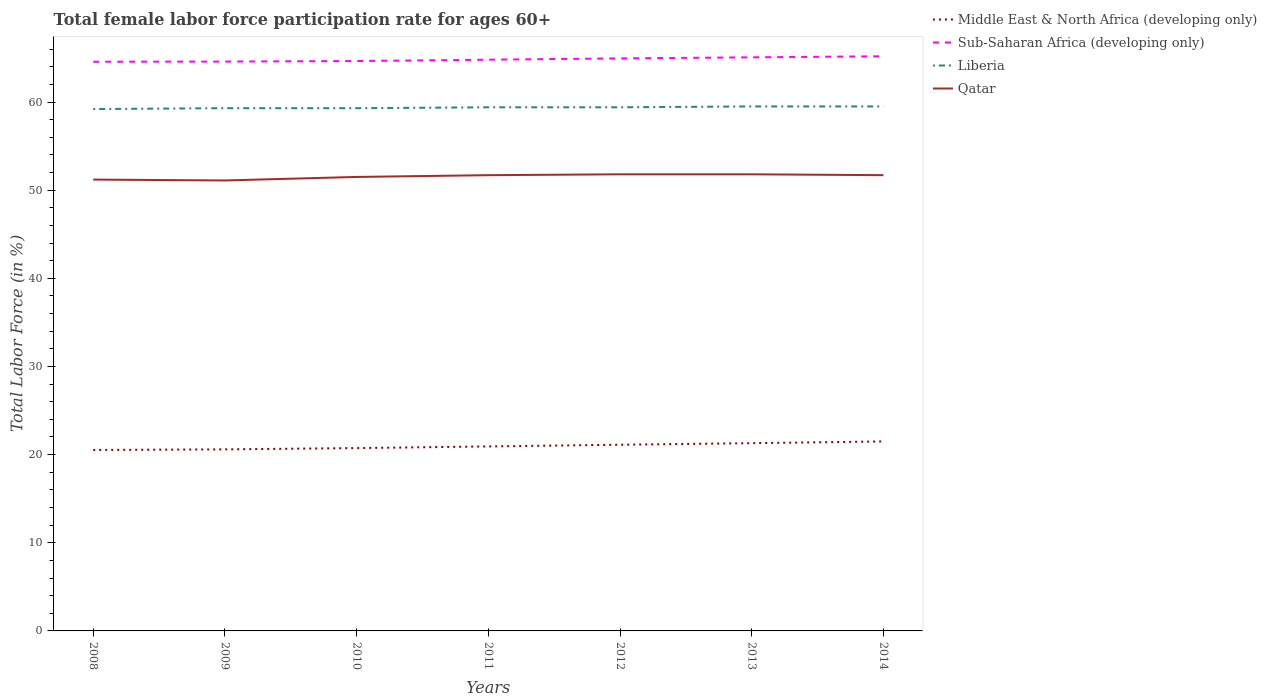Is the number of lines equal to the number of legend labels?
Offer a terse response. Yes. Across all years, what is the maximum female labor force participation rate in Liberia?
Make the answer very short. 59.2. What is the total female labor force participation rate in Middle East & North Africa (developing only) in the graph?
Your answer should be compact. -0.19. What is the difference between the highest and the second highest female labor force participation rate in Liberia?
Offer a terse response. 0.3. What is the difference between the highest and the lowest female labor force participation rate in Qatar?
Provide a succinct answer. 4. Is the female labor force participation rate in Qatar strictly greater than the female labor force participation rate in Liberia over the years?
Provide a succinct answer. Yes. How many years are there in the graph?
Provide a succinct answer. 7. What is the difference between two consecutive major ticks on the Y-axis?
Keep it short and to the point. 10. Are the values on the major ticks of Y-axis written in scientific E-notation?
Ensure brevity in your answer.  No. Where does the legend appear in the graph?
Make the answer very short. Top right. How are the legend labels stacked?
Your response must be concise. Vertical. What is the title of the graph?
Offer a very short reply. Total female labor force participation rate for ages 60+. Does "Euro area" appear as one of the legend labels in the graph?
Offer a very short reply. No. What is the Total Labor Force (in %) of Middle East & North Africa (developing only) in 2008?
Give a very brief answer. 20.53. What is the Total Labor Force (in %) in Sub-Saharan Africa (developing only) in 2008?
Make the answer very short. 64.57. What is the Total Labor Force (in %) in Liberia in 2008?
Your answer should be compact. 59.2. What is the Total Labor Force (in %) in Qatar in 2008?
Provide a succinct answer. 51.2. What is the Total Labor Force (in %) of Middle East & North Africa (developing only) in 2009?
Make the answer very short. 20.59. What is the Total Labor Force (in %) of Sub-Saharan Africa (developing only) in 2009?
Keep it short and to the point. 64.59. What is the Total Labor Force (in %) of Liberia in 2009?
Keep it short and to the point. 59.3. What is the Total Labor Force (in %) of Qatar in 2009?
Provide a short and direct response. 51.1. What is the Total Labor Force (in %) in Middle East & North Africa (developing only) in 2010?
Offer a terse response. 20.74. What is the Total Labor Force (in %) in Sub-Saharan Africa (developing only) in 2010?
Offer a very short reply. 64.65. What is the Total Labor Force (in %) in Liberia in 2010?
Your response must be concise. 59.3. What is the Total Labor Force (in %) of Qatar in 2010?
Your response must be concise. 51.5. What is the Total Labor Force (in %) in Middle East & North Africa (developing only) in 2011?
Your response must be concise. 20.93. What is the Total Labor Force (in %) of Sub-Saharan Africa (developing only) in 2011?
Provide a succinct answer. 64.8. What is the Total Labor Force (in %) in Liberia in 2011?
Offer a very short reply. 59.4. What is the Total Labor Force (in %) in Qatar in 2011?
Your response must be concise. 51.7. What is the Total Labor Force (in %) of Middle East & North Africa (developing only) in 2012?
Your answer should be very brief. 21.12. What is the Total Labor Force (in %) in Sub-Saharan Africa (developing only) in 2012?
Offer a terse response. 64.95. What is the Total Labor Force (in %) in Liberia in 2012?
Offer a terse response. 59.4. What is the Total Labor Force (in %) in Qatar in 2012?
Offer a terse response. 51.8. What is the Total Labor Force (in %) in Middle East & North Africa (developing only) in 2013?
Make the answer very short. 21.3. What is the Total Labor Force (in %) in Sub-Saharan Africa (developing only) in 2013?
Your answer should be compact. 65.07. What is the Total Labor Force (in %) in Liberia in 2013?
Your response must be concise. 59.5. What is the Total Labor Force (in %) in Qatar in 2013?
Your answer should be compact. 51.8. What is the Total Labor Force (in %) in Middle East & North Africa (developing only) in 2014?
Offer a very short reply. 21.5. What is the Total Labor Force (in %) in Sub-Saharan Africa (developing only) in 2014?
Offer a terse response. 65.19. What is the Total Labor Force (in %) in Liberia in 2014?
Give a very brief answer. 59.5. What is the Total Labor Force (in %) of Qatar in 2014?
Offer a terse response. 51.7. Across all years, what is the maximum Total Labor Force (in %) of Middle East & North Africa (developing only)?
Offer a terse response. 21.5. Across all years, what is the maximum Total Labor Force (in %) of Sub-Saharan Africa (developing only)?
Offer a very short reply. 65.19. Across all years, what is the maximum Total Labor Force (in %) of Liberia?
Provide a short and direct response. 59.5. Across all years, what is the maximum Total Labor Force (in %) in Qatar?
Provide a short and direct response. 51.8. Across all years, what is the minimum Total Labor Force (in %) of Middle East & North Africa (developing only)?
Provide a short and direct response. 20.53. Across all years, what is the minimum Total Labor Force (in %) of Sub-Saharan Africa (developing only)?
Provide a short and direct response. 64.57. Across all years, what is the minimum Total Labor Force (in %) of Liberia?
Your response must be concise. 59.2. Across all years, what is the minimum Total Labor Force (in %) in Qatar?
Your answer should be compact. 51.1. What is the total Total Labor Force (in %) in Middle East & North Africa (developing only) in the graph?
Your answer should be very brief. 146.71. What is the total Total Labor Force (in %) in Sub-Saharan Africa (developing only) in the graph?
Keep it short and to the point. 453.81. What is the total Total Labor Force (in %) in Liberia in the graph?
Your answer should be very brief. 415.6. What is the total Total Labor Force (in %) in Qatar in the graph?
Your response must be concise. 360.8. What is the difference between the Total Labor Force (in %) of Middle East & North Africa (developing only) in 2008 and that in 2009?
Your answer should be compact. -0.06. What is the difference between the Total Labor Force (in %) of Sub-Saharan Africa (developing only) in 2008 and that in 2009?
Your response must be concise. -0.02. What is the difference between the Total Labor Force (in %) of Qatar in 2008 and that in 2009?
Provide a short and direct response. 0.1. What is the difference between the Total Labor Force (in %) in Middle East & North Africa (developing only) in 2008 and that in 2010?
Give a very brief answer. -0.21. What is the difference between the Total Labor Force (in %) in Sub-Saharan Africa (developing only) in 2008 and that in 2010?
Provide a succinct answer. -0.08. What is the difference between the Total Labor Force (in %) of Qatar in 2008 and that in 2010?
Your answer should be very brief. -0.3. What is the difference between the Total Labor Force (in %) in Middle East & North Africa (developing only) in 2008 and that in 2011?
Provide a succinct answer. -0.4. What is the difference between the Total Labor Force (in %) of Sub-Saharan Africa (developing only) in 2008 and that in 2011?
Provide a short and direct response. -0.23. What is the difference between the Total Labor Force (in %) in Liberia in 2008 and that in 2011?
Ensure brevity in your answer.  -0.2. What is the difference between the Total Labor Force (in %) of Qatar in 2008 and that in 2011?
Provide a short and direct response. -0.5. What is the difference between the Total Labor Force (in %) in Middle East & North Africa (developing only) in 2008 and that in 2012?
Make the answer very short. -0.59. What is the difference between the Total Labor Force (in %) of Sub-Saharan Africa (developing only) in 2008 and that in 2012?
Your answer should be compact. -0.38. What is the difference between the Total Labor Force (in %) of Qatar in 2008 and that in 2012?
Your answer should be compact. -0.6. What is the difference between the Total Labor Force (in %) in Middle East & North Africa (developing only) in 2008 and that in 2013?
Keep it short and to the point. -0.77. What is the difference between the Total Labor Force (in %) in Sub-Saharan Africa (developing only) in 2008 and that in 2013?
Keep it short and to the point. -0.5. What is the difference between the Total Labor Force (in %) in Liberia in 2008 and that in 2013?
Offer a very short reply. -0.3. What is the difference between the Total Labor Force (in %) of Qatar in 2008 and that in 2013?
Offer a very short reply. -0.6. What is the difference between the Total Labor Force (in %) of Middle East & North Africa (developing only) in 2008 and that in 2014?
Your answer should be very brief. -0.97. What is the difference between the Total Labor Force (in %) in Sub-Saharan Africa (developing only) in 2008 and that in 2014?
Provide a short and direct response. -0.62. What is the difference between the Total Labor Force (in %) in Qatar in 2008 and that in 2014?
Offer a terse response. -0.5. What is the difference between the Total Labor Force (in %) of Middle East & North Africa (developing only) in 2009 and that in 2010?
Make the answer very short. -0.15. What is the difference between the Total Labor Force (in %) in Sub-Saharan Africa (developing only) in 2009 and that in 2010?
Provide a succinct answer. -0.06. What is the difference between the Total Labor Force (in %) of Liberia in 2009 and that in 2010?
Give a very brief answer. 0. What is the difference between the Total Labor Force (in %) of Qatar in 2009 and that in 2010?
Make the answer very short. -0.4. What is the difference between the Total Labor Force (in %) of Middle East & North Africa (developing only) in 2009 and that in 2011?
Offer a very short reply. -0.34. What is the difference between the Total Labor Force (in %) of Sub-Saharan Africa (developing only) in 2009 and that in 2011?
Ensure brevity in your answer.  -0.21. What is the difference between the Total Labor Force (in %) in Liberia in 2009 and that in 2011?
Provide a short and direct response. -0.1. What is the difference between the Total Labor Force (in %) in Qatar in 2009 and that in 2011?
Provide a succinct answer. -0.6. What is the difference between the Total Labor Force (in %) in Middle East & North Africa (developing only) in 2009 and that in 2012?
Provide a succinct answer. -0.53. What is the difference between the Total Labor Force (in %) of Sub-Saharan Africa (developing only) in 2009 and that in 2012?
Your response must be concise. -0.36. What is the difference between the Total Labor Force (in %) of Liberia in 2009 and that in 2012?
Give a very brief answer. -0.1. What is the difference between the Total Labor Force (in %) in Qatar in 2009 and that in 2012?
Offer a very short reply. -0.7. What is the difference between the Total Labor Force (in %) in Middle East & North Africa (developing only) in 2009 and that in 2013?
Offer a very short reply. -0.7. What is the difference between the Total Labor Force (in %) in Sub-Saharan Africa (developing only) in 2009 and that in 2013?
Make the answer very short. -0.48. What is the difference between the Total Labor Force (in %) in Liberia in 2009 and that in 2013?
Make the answer very short. -0.2. What is the difference between the Total Labor Force (in %) of Middle East & North Africa (developing only) in 2009 and that in 2014?
Make the answer very short. -0.9. What is the difference between the Total Labor Force (in %) in Sub-Saharan Africa (developing only) in 2009 and that in 2014?
Your answer should be very brief. -0.6. What is the difference between the Total Labor Force (in %) in Liberia in 2009 and that in 2014?
Ensure brevity in your answer.  -0.2. What is the difference between the Total Labor Force (in %) of Qatar in 2009 and that in 2014?
Your response must be concise. -0.6. What is the difference between the Total Labor Force (in %) of Middle East & North Africa (developing only) in 2010 and that in 2011?
Provide a succinct answer. -0.19. What is the difference between the Total Labor Force (in %) in Sub-Saharan Africa (developing only) in 2010 and that in 2011?
Ensure brevity in your answer.  -0.15. What is the difference between the Total Labor Force (in %) of Liberia in 2010 and that in 2011?
Your answer should be very brief. -0.1. What is the difference between the Total Labor Force (in %) in Qatar in 2010 and that in 2011?
Give a very brief answer. -0.2. What is the difference between the Total Labor Force (in %) in Middle East & North Africa (developing only) in 2010 and that in 2012?
Your answer should be compact. -0.38. What is the difference between the Total Labor Force (in %) of Sub-Saharan Africa (developing only) in 2010 and that in 2012?
Keep it short and to the point. -0.3. What is the difference between the Total Labor Force (in %) in Qatar in 2010 and that in 2012?
Make the answer very short. -0.3. What is the difference between the Total Labor Force (in %) of Middle East & North Africa (developing only) in 2010 and that in 2013?
Your answer should be very brief. -0.56. What is the difference between the Total Labor Force (in %) of Sub-Saharan Africa (developing only) in 2010 and that in 2013?
Provide a succinct answer. -0.42. What is the difference between the Total Labor Force (in %) of Liberia in 2010 and that in 2013?
Your answer should be compact. -0.2. What is the difference between the Total Labor Force (in %) of Qatar in 2010 and that in 2013?
Your response must be concise. -0.3. What is the difference between the Total Labor Force (in %) of Middle East & North Africa (developing only) in 2010 and that in 2014?
Provide a succinct answer. -0.75. What is the difference between the Total Labor Force (in %) of Sub-Saharan Africa (developing only) in 2010 and that in 2014?
Your answer should be very brief. -0.54. What is the difference between the Total Labor Force (in %) of Liberia in 2010 and that in 2014?
Offer a terse response. -0.2. What is the difference between the Total Labor Force (in %) in Middle East & North Africa (developing only) in 2011 and that in 2012?
Keep it short and to the point. -0.19. What is the difference between the Total Labor Force (in %) of Sub-Saharan Africa (developing only) in 2011 and that in 2012?
Your answer should be compact. -0.15. What is the difference between the Total Labor Force (in %) of Liberia in 2011 and that in 2012?
Ensure brevity in your answer.  0. What is the difference between the Total Labor Force (in %) of Qatar in 2011 and that in 2012?
Offer a terse response. -0.1. What is the difference between the Total Labor Force (in %) in Middle East & North Africa (developing only) in 2011 and that in 2013?
Offer a very short reply. -0.37. What is the difference between the Total Labor Force (in %) of Sub-Saharan Africa (developing only) in 2011 and that in 2013?
Keep it short and to the point. -0.27. What is the difference between the Total Labor Force (in %) of Liberia in 2011 and that in 2013?
Your response must be concise. -0.1. What is the difference between the Total Labor Force (in %) of Qatar in 2011 and that in 2013?
Give a very brief answer. -0.1. What is the difference between the Total Labor Force (in %) in Middle East & North Africa (developing only) in 2011 and that in 2014?
Provide a short and direct response. -0.57. What is the difference between the Total Labor Force (in %) in Sub-Saharan Africa (developing only) in 2011 and that in 2014?
Your answer should be compact. -0.39. What is the difference between the Total Labor Force (in %) of Qatar in 2011 and that in 2014?
Your answer should be very brief. 0. What is the difference between the Total Labor Force (in %) in Middle East & North Africa (developing only) in 2012 and that in 2013?
Give a very brief answer. -0.18. What is the difference between the Total Labor Force (in %) in Sub-Saharan Africa (developing only) in 2012 and that in 2013?
Provide a succinct answer. -0.12. What is the difference between the Total Labor Force (in %) in Liberia in 2012 and that in 2013?
Give a very brief answer. -0.1. What is the difference between the Total Labor Force (in %) in Middle East & North Africa (developing only) in 2012 and that in 2014?
Your answer should be compact. -0.38. What is the difference between the Total Labor Force (in %) of Sub-Saharan Africa (developing only) in 2012 and that in 2014?
Your answer should be very brief. -0.24. What is the difference between the Total Labor Force (in %) of Liberia in 2012 and that in 2014?
Offer a terse response. -0.1. What is the difference between the Total Labor Force (in %) in Middle East & North Africa (developing only) in 2013 and that in 2014?
Make the answer very short. -0.2. What is the difference between the Total Labor Force (in %) of Sub-Saharan Africa (developing only) in 2013 and that in 2014?
Your answer should be compact. -0.12. What is the difference between the Total Labor Force (in %) of Qatar in 2013 and that in 2014?
Ensure brevity in your answer.  0.1. What is the difference between the Total Labor Force (in %) in Middle East & North Africa (developing only) in 2008 and the Total Labor Force (in %) in Sub-Saharan Africa (developing only) in 2009?
Your response must be concise. -44.06. What is the difference between the Total Labor Force (in %) of Middle East & North Africa (developing only) in 2008 and the Total Labor Force (in %) of Liberia in 2009?
Give a very brief answer. -38.77. What is the difference between the Total Labor Force (in %) in Middle East & North Africa (developing only) in 2008 and the Total Labor Force (in %) in Qatar in 2009?
Make the answer very short. -30.57. What is the difference between the Total Labor Force (in %) in Sub-Saharan Africa (developing only) in 2008 and the Total Labor Force (in %) in Liberia in 2009?
Your response must be concise. 5.27. What is the difference between the Total Labor Force (in %) in Sub-Saharan Africa (developing only) in 2008 and the Total Labor Force (in %) in Qatar in 2009?
Ensure brevity in your answer.  13.47. What is the difference between the Total Labor Force (in %) in Middle East & North Africa (developing only) in 2008 and the Total Labor Force (in %) in Sub-Saharan Africa (developing only) in 2010?
Provide a succinct answer. -44.12. What is the difference between the Total Labor Force (in %) of Middle East & North Africa (developing only) in 2008 and the Total Labor Force (in %) of Liberia in 2010?
Your response must be concise. -38.77. What is the difference between the Total Labor Force (in %) of Middle East & North Africa (developing only) in 2008 and the Total Labor Force (in %) of Qatar in 2010?
Your answer should be very brief. -30.97. What is the difference between the Total Labor Force (in %) in Sub-Saharan Africa (developing only) in 2008 and the Total Labor Force (in %) in Liberia in 2010?
Your answer should be compact. 5.27. What is the difference between the Total Labor Force (in %) in Sub-Saharan Africa (developing only) in 2008 and the Total Labor Force (in %) in Qatar in 2010?
Ensure brevity in your answer.  13.07. What is the difference between the Total Labor Force (in %) in Middle East & North Africa (developing only) in 2008 and the Total Labor Force (in %) in Sub-Saharan Africa (developing only) in 2011?
Provide a succinct answer. -44.27. What is the difference between the Total Labor Force (in %) of Middle East & North Africa (developing only) in 2008 and the Total Labor Force (in %) of Liberia in 2011?
Offer a very short reply. -38.87. What is the difference between the Total Labor Force (in %) of Middle East & North Africa (developing only) in 2008 and the Total Labor Force (in %) of Qatar in 2011?
Offer a terse response. -31.17. What is the difference between the Total Labor Force (in %) of Sub-Saharan Africa (developing only) in 2008 and the Total Labor Force (in %) of Liberia in 2011?
Ensure brevity in your answer.  5.17. What is the difference between the Total Labor Force (in %) in Sub-Saharan Africa (developing only) in 2008 and the Total Labor Force (in %) in Qatar in 2011?
Your response must be concise. 12.87. What is the difference between the Total Labor Force (in %) in Liberia in 2008 and the Total Labor Force (in %) in Qatar in 2011?
Your answer should be very brief. 7.5. What is the difference between the Total Labor Force (in %) in Middle East & North Africa (developing only) in 2008 and the Total Labor Force (in %) in Sub-Saharan Africa (developing only) in 2012?
Ensure brevity in your answer.  -44.42. What is the difference between the Total Labor Force (in %) of Middle East & North Africa (developing only) in 2008 and the Total Labor Force (in %) of Liberia in 2012?
Offer a terse response. -38.87. What is the difference between the Total Labor Force (in %) in Middle East & North Africa (developing only) in 2008 and the Total Labor Force (in %) in Qatar in 2012?
Keep it short and to the point. -31.27. What is the difference between the Total Labor Force (in %) of Sub-Saharan Africa (developing only) in 2008 and the Total Labor Force (in %) of Liberia in 2012?
Provide a succinct answer. 5.17. What is the difference between the Total Labor Force (in %) of Sub-Saharan Africa (developing only) in 2008 and the Total Labor Force (in %) of Qatar in 2012?
Ensure brevity in your answer.  12.77. What is the difference between the Total Labor Force (in %) in Liberia in 2008 and the Total Labor Force (in %) in Qatar in 2012?
Your response must be concise. 7.4. What is the difference between the Total Labor Force (in %) in Middle East & North Africa (developing only) in 2008 and the Total Labor Force (in %) in Sub-Saharan Africa (developing only) in 2013?
Offer a terse response. -44.54. What is the difference between the Total Labor Force (in %) in Middle East & North Africa (developing only) in 2008 and the Total Labor Force (in %) in Liberia in 2013?
Keep it short and to the point. -38.97. What is the difference between the Total Labor Force (in %) in Middle East & North Africa (developing only) in 2008 and the Total Labor Force (in %) in Qatar in 2013?
Provide a short and direct response. -31.27. What is the difference between the Total Labor Force (in %) of Sub-Saharan Africa (developing only) in 2008 and the Total Labor Force (in %) of Liberia in 2013?
Your response must be concise. 5.07. What is the difference between the Total Labor Force (in %) in Sub-Saharan Africa (developing only) in 2008 and the Total Labor Force (in %) in Qatar in 2013?
Your answer should be very brief. 12.77. What is the difference between the Total Labor Force (in %) in Middle East & North Africa (developing only) in 2008 and the Total Labor Force (in %) in Sub-Saharan Africa (developing only) in 2014?
Make the answer very short. -44.66. What is the difference between the Total Labor Force (in %) in Middle East & North Africa (developing only) in 2008 and the Total Labor Force (in %) in Liberia in 2014?
Provide a succinct answer. -38.97. What is the difference between the Total Labor Force (in %) of Middle East & North Africa (developing only) in 2008 and the Total Labor Force (in %) of Qatar in 2014?
Offer a very short reply. -31.17. What is the difference between the Total Labor Force (in %) of Sub-Saharan Africa (developing only) in 2008 and the Total Labor Force (in %) of Liberia in 2014?
Make the answer very short. 5.07. What is the difference between the Total Labor Force (in %) of Sub-Saharan Africa (developing only) in 2008 and the Total Labor Force (in %) of Qatar in 2014?
Keep it short and to the point. 12.87. What is the difference between the Total Labor Force (in %) of Middle East & North Africa (developing only) in 2009 and the Total Labor Force (in %) of Sub-Saharan Africa (developing only) in 2010?
Offer a terse response. -44.05. What is the difference between the Total Labor Force (in %) in Middle East & North Africa (developing only) in 2009 and the Total Labor Force (in %) in Liberia in 2010?
Give a very brief answer. -38.71. What is the difference between the Total Labor Force (in %) in Middle East & North Africa (developing only) in 2009 and the Total Labor Force (in %) in Qatar in 2010?
Keep it short and to the point. -30.91. What is the difference between the Total Labor Force (in %) of Sub-Saharan Africa (developing only) in 2009 and the Total Labor Force (in %) of Liberia in 2010?
Ensure brevity in your answer.  5.29. What is the difference between the Total Labor Force (in %) of Sub-Saharan Africa (developing only) in 2009 and the Total Labor Force (in %) of Qatar in 2010?
Offer a very short reply. 13.09. What is the difference between the Total Labor Force (in %) in Middle East & North Africa (developing only) in 2009 and the Total Labor Force (in %) in Sub-Saharan Africa (developing only) in 2011?
Offer a very short reply. -44.21. What is the difference between the Total Labor Force (in %) in Middle East & North Africa (developing only) in 2009 and the Total Labor Force (in %) in Liberia in 2011?
Make the answer very short. -38.81. What is the difference between the Total Labor Force (in %) of Middle East & North Africa (developing only) in 2009 and the Total Labor Force (in %) of Qatar in 2011?
Offer a terse response. -31.11. What is the difference between the Total Labor Force (in %) of Sub-Saharan Africa (developing only) in 2009 and the Total Labor Force (in %) of Liberia in 2011?
Ensure brevity in your answer.  5.19. What is the difference between the Total Labor Force (in %) in Sub-Saharan Africa (developing only) in 2009 and the Total Labor Force (in %) in Qatar in 2011?
Provide a short and direct response. 12.89. What is the difference between the Total Labor Force (in %) in Middle East & North Africa (developing only) in 2009 and the Total Labor Force (in %) in Sub-Saharan Africa (developing only) in 2012?
Provide a succinct answer. -44.35. What is the difference between the Total Labor Force (in %) of Middle East & North Africa (developing only) in 2009 and the Total Labor Force (in %) of Liberia in 2012?
Offer a very short reply. -38.81. What is the difference between the Total Labor Force (in %) in Middle East & North Africa (developing only) in 2009 and the Total Labor Force (in %) in Qatar in 2012?
Your response must be concise. -31.21. What is the difference between the Total Labor Force (in %) in Sub-Saharan Africa (developing only) in 2009 and the Total Labor Force (in %) in Liberia in 2012?
Keep it short and to the point. 5.19. What is the difference between the Total Labor Force (in %) in Sub-Saharan Africa (developing only) in 2009 and the Total Labor Force (in %) in Qatar in 2012?
Your response must be concise. 12.79. What is the difference between the Total Labor Force (in %) in Liberia in 2009 and the Total Labor Force (in %) in Qatar in 2012?
Your answer should be very brief. 7.5. What is the difference between the Total Labor Force (in %) in Middle East & North Africa (developing only) in 2009 and the Total Labor Force (in %) in Sub-Saharan Africa (developing only) in 2013?
Your answer should be compact. -44.47. What is the difference between the Total Labor Force (in %) of Middle East & North Africa (developing only) in 2009 and the Total Labor Force (in %) of Liberia in 2013?
Your response must be concise. -38.91. What is the difference between the Total Labor Force (in %) of Middle East & North Africa (developing only) in 2009 and the Total Labor Force (in %) of Qatar in 2013?
Your answer should be compact. -31.21. What is the difference between the Total Labor Force (in %) of Sub-Saharan Africa (developing only) in 2009 and the Total Labor Force (in %) of Liberia in 2013?
Ensure brevity in your answer.  5.09. What is the difference between the Total Labor Force (in %) of Sub-Saharan Africa (developing only) in 2009 and the Total Labor Force (in %) of Qatar in 2013?
Make the answer very short. 12.79. What is the difference between the Total Labor Force (in %) of Liberia in 2009 and the Total Labor Force (in %) of Qatar in 2013?
Your response must be concise. 7.5. What is the difference between the Total Labor Force (in %) in Middle East & North Africa (developing only) in 2009 and the Total Labor Force (in %) in Sub-Saharan Africa (developing only) in 2014?
Give a very brief answer. -44.6. What is the difference between the Total Labor Force (in %) of Middle East & North Africa (developing only) in 2009 and the Total Labor Force (in %) of Liberia in 2014?
Make the answer very short. -38.91. What is the difference between the Total Labor Force (in %) of Middle East & North Africa (developing only) in 2009 and the Total Labor Force (in %) of Qatar in 2014?
Make the answer very short. -31.11. What is the difference between the Total Labor Force (in %) of Sub-Saharan Africa (developing only) in 2009 and the Total Labor Force (in %) of Liberia in 2014?
Provide a succinct answer. 5.09. What is the difference between the Total Labor Force (in %) in Sub-Saharan Africa (developing only) in 2009 and the Total Labor Force (in %) in Qatar in 2014?
Keep it short and to the point. 12.89. What is the difference between the Total Labor Force (in %) in Middle East & North Africa (developing only) in 2010 and the Total Labor Force (in %) in Sub-Saharan Africa (developing only) in 2011?
Provide a succinct answer. -44.06. What is the difference between the Total Labor Force (in %) of Middle East & North Africa (developing only) in 2010 and the Total Labor Force (in %) of Liberia in 2011?
Give a very brief answer. -38.66. What is the difference between the Total Labor Force (in %) of Middle East & North Africa (developing only) in 2010 and the Total Labor Force (in %) of Qatar in 2011?
Provide a succinct answer. -30.96. What is the difference between the Total Labor Force (in %) in Sub-Saharan Africa (developing only) in 2010 and the Total Labor Force (in %) in Liberia in 2011?
Keep it short and to the point. 5.25. What is the difference between the Total Labor Force (in %) of Sub-Saharan Africa (developing only) in 2010 and the Total Labor Force (in %) of Qatar in 2011?
Keep it short and to the point. 12.95. What is the difference between the Total Labor Force (in %) of Liberia in 2010 and the Total Labor Force (in %) of Qatar in 2011?
Make the answer very short. 7.6. What is the difference between the Total Labor Force (in %) in Middle East & North Africa (developing only) in 2010 and the Total Labor Force (in %) in Sub-Saharan Africa (developing only) in 2012?
Ensure brevity in your answer.  -44.21. What is the difference between the Total Labor Force (in %) in Middle East & North Africa (developing only) in 2010 and the Total Labor Force (in %) in Liberia in 2012?
Your answer should be compact. -38.66. What is the difference between the Total Labor Force (in %) in Middle East & North Africa (developing only) in 2010 and the Total Labor Force (in %) in Qatar in 2012?
Give a very brief answer. -31.06. What is the difference between the Total Labor Force (in %) in Sub-Saharan Africa (developing only) in 2010 and the Total Labor Force (in %) in Liberia in 2012?
Your answer should be very brief. 5.25. What is the difference between the Total Labor Force (in %) of Sub-Saharan Africa (developing only) in 2010 and the Total Labor Force (in %) of Qatar in 2012?
Your response must be concise. 12.85. What is the difference between the Total Labor Force (in %) of Middle East & North Africa (developing only) in 2010 and the Total Labor Force (in %) of Sub-Saharan Africa (developing only) in 2013?
Your answer should be very brief. -44.33. What is the difference between the Total Labor Force (in %) of Middle East & North Africa (developing only) in 2010 and the Total Labor Force (in %) of Liberia in 2013?
Provide a succinct answer. -38.76. What is the difference between the Total Labor Force (in %) of Middle East & North Africa (developing only) in 2010 and the Total Labor Force (in %) of Qatar in 2013?
Your response must be concise. -31.06. What is the difference between the Total Labor Force (in %) in Sub-Saharan Africa (developing only) in 2010 and the Total Labor Force (in %) in Liberia in 2013?
Give a very brief answer. 5.15. What is the difference between the Total Labor Force (in %) of Sub-Saharan Africa (developing only) in 2010 and the Total Labor Force (in %) of Qatar in 2013?
Your answer should be very brief. 12.85. What is the difference between the Total Labor Force (in %) in Middle East & North Africa (developing only) in 2010 and the Total Labor Force (in %) in Sub-Saharan Africa (developing only) in 2014?
Your answer should be compact. -44.45. What is the difference between the Total Labor Force (in %) of Middle East & North Africa (developing only) in 2010 and the Total Labor Force (in %) of Liberia in 2014?
Offer a very short reply. -38.76. What is the difference between the Total Labor Force (in %) of Middle East & North Africa (developing only) in 2010 and the Total Labor Force (in %) of Qatar in 2014?
Your answer should be compact. -30.96. What is the difference between the Total Labor Force (in %) of Sub-Saharan Africa (developing only) in 2010 and the Total Labor Force (in %) of Liberia in 2014?
Offer a very short reply. 5.15. What is the difference between the Total Labor Force (in %) in Sub-Saharan Africa (developing only) in 2010 and the Total Labor Force (in %) in Qatar in 2014?
Offer a terse response. 12.95. What is the difference between the Total Labor Force (in %) in Middle East & North Africa (developing only) in 2011 and the Total Labor Force (in %) in Sub-Saharan Africa (developing only) in 2012?
Provide a succinct answer. -44.02. What is the difference between the Total Labor Force (in %) in Middle East & North Africa (developing only) in 2011 and the Total Labor Force (in %) in Liberia in 2012?
Offer a very short reply. -38.47. What is the difference between the Total Labor Force (in %) in Middle East & North Africa (developing only) in 2011 and the Total Labor Force (in %) in Qatar in 2012?
Your answer should be very brief. -30.87. What is the difference between the Total Labor Force (in %) in Sub-Saharan Africa (developing only) in 2011 and the Total Labor Force (in %) in Liberia in 2012?
Your answer should be very brief. 5.4. What is the difference between the Total Labor Force (in %) in Sub-Saharan Africa (developing only) in 2011 and the Total Labor Force (in %) in Qatar in 2012?
Offer a terse response. 13. What is the difference between the Total Labor Force (in %) in Middle East & North Africa (developing only) in 2011 and the Total Labor Force (in %) in Sub-Saharan Africa (developing only) in 2013?
Your answer should be very brief. -44.14. What is the difference between the Total Labor Force (in %) of Middle East & North Africa (developing only) in 2011 and the Total Labor Force (in %) of Liberia in 2013?
Your answer should be compact. -38.57. What is the difference between the Total Labor Force (in %) of Middle East & North Africa (developing only) in 2011 and the Total Labor Force (in %) of Qatar in 2013?
Your response must be concise. -30.87. What is the difference between the Total Labor Force (in %) in Sub-Saharan Africa (developing only) in 2011 and the Total Labor Force (in %) in Liberia in 2013?
Ensure brevity in your answer.  5.3. What is the difference between the Total Labor Force (in %) in Sub-Saharan Africa (developing only) in 2011 and the Total Labor Force (in %) in Qatar in 2013?
Provide a short and direct response. 13. What is the difference between the Total Labor Force (in %) in Middle East & North Africa (developing only) in 2011 and the Total Labor Force (in %) in Sub-Saharan Africa (developing only) in 2014?
Your answer should be compact. -44.26. What is the difference between the Total Labor Force (in %) in Middle East & North Africa (developing only) in 2011 and the Total Labor Force (in %) in Liberia in 2014?
Your answer should be very brief. -38.57. What is the difference between the Total Labor Force (in %) in Middle East & North Africa (developing only) in 2011 and the Total Labor Force (in %) in Qatar in 2014?
Your response must be concise. -30.77. What is the difference between the Total Labor Force (in %) in Sub-Saharan Africa (developing only) in 2011 and the Total Labor Force (in %) in Liberia in 2014?
Your response must be concise. 5.3. What is the difference between the Total Labor Force (in %) of Sub-Saharan Africa (developing only) in 2011 and the Total Labor Force (in %) of Qatar in 2014?
Make the answer very short. 13.1. What is the difference between the Total Labor Force (in %) in Middle East & North Africa (developing only) in 2012 and the Total Labor Force (in %) in Sub-Saharan Africa (developing only) in 2013?
Keep it short and to the point. -43.95. What is the difference between the Total Labor Force (in %) in Middle East & North Africa (developing only) in 2012 and the Total Labor Force (in %) in Liberia in 2013?
Ensure brevity in your answer.  -38.38. What is the difference between the Total Labor Force (in %) in Middle East & North Africa (developing only) in 2012 and the Total Labor Force (in %) in Qatar in 2013?
Offer a very short reply. -30.68. What is the difference between the Total Labor Force (in %) in Sub-Saharan Africa (developing only) in 2012 and the Total Labor Force (in %) in Liberia in 2013?
Offer a very short reply. 5.45. What is the difference between the Total Labor Force (in %) in Sub-Saharan Africa (developing only) in 2012 and the Total Labor Force (in %) in Qatar in 2013?
Your answer should be very brief. 13.15. What is the difference between the Total Labor Force (in %) of Middle East & North Africa (developing only) in 2012 and the Total Labor Force (in %) of Sub-Saharan Africa (developing only) in 2014?
Your response must be concise. -44.07. What is the difference between the Total Labor Force (in %) in Middle East & North Africa (developing only) in 2012 and the Total Labor Force (in %) in Liberia in 2014?
Provide a short and direct response. -38.38. What is the difference between the Total Labor Force (in %) of Middle East & North Africa (developing only) in 2012 and the Total Labor Force (in %) of Qatar in 2014?
Provide a succinct answer. -30.58. What is the difference between the Total Labor Force (in %) in Sub-Saharan Africa (developing only) in 2012 and the Total Labor Force (in %) in Liberia in 2014?
Provide a short and direct response. 5.45. What is the difference between the Total Labor Force (in %) in Sub-Saharan Africa (developing only) in 2012 and the Total Labor Force (in %) in Qatar in 2014?
Keep it short and to the point. 13.25. What is the difference between the Total Labor Force (in %) of Middle East & North Africa (developing only) in 2013 and the Total Labor Force (in %) of Sub-Saharan Africa (developing only) in 2014?
Provide a succinct answer. -43.89. What is the difference between the Total Labor Force (in %) of Middle East & North Africa (developing only) in 2013 and the Total Labor Force (in %) of Liberia in 2014?
Your answer should be very brief. -38.2. What is the difference between the Total Labor Force (in %) in Middle East & North Africa (developing only) in 2013 and the Total Labor Force (in %) in Qatar in 2014?
Make the answer very short. -30.4. What is the difference between the Total Labor Force (in %) of Sub-Saharan Africa (developing only) in 2013 and the Total Labor Force (in %) of Liberia in 2014?
Your answer should be very brief. 5.57. What is the difference between the Total Labor Force (in %) of Sub-Saharan Africa (developing only) in 2013 and the Total Labor Force (in %) of Qatar in 2014?
Provide a succinct answer. 13.37. What is the difference between the Total Labor Force (in %) in Liberia in 2013 and the Total Labor Force (in %) in Qatar in 2014?
Make the answer very short. 7.8. What is the average Total Labor Force (in %) of Middle East & North Africa (developing only) per year?
Provide a succinct answer. 20.96. What is the average Total Labor Force (in %) of Sub-Saharan Africa (developing only) per year?
Ensure brevity in your answer.  64.83. What is the average Total Labor Force (in %) of Liberia per year?
Offer a very short reply. 59.37. What is the average Total Labor Force (in %) of Qatar per year?
Your answer should be very brief. 51.54. In the year 2008, what is the difference between the Total Labor Force (in %) in Middle East & North Africa (developing only) and Total Labor Force (in %) in Sub-Saharan Africa (developing only)?
Keep it short and to the point. -44.04. In the year 2008, what is the difference between the Total Labor Force (in %) in Middle East & North Africa (developing only) and Total Labor Force (in %) in Liberia?
Provide a short and direct response. -38.67. In the year 2008, what is the difference between the Total Labor Force (in %) in Middle East & North Africa (developing only) and Total Labor Force (in %) in Qatar?
Provide a short and direct response. -30.67. In the year 2008, what is the difference between the Total Labor Force (in %) of Sub-Saharan Africa (developing only) and Total Labor Force (in %) of Liberia?
Your response must be concise. 5.37. In the year 2008, what is the difference between the Total Labor Force (in %) in Sub-Saharan Africa (developing only) and Total Labor Force (in %) in Qatar?
Ensure brevity in your answer.  13.37. In the year 2009, what is the difference between the Total Labor Force (in %) in Middle East & North Africa (developing only) and Total Labor Force (in %) in Sub-Saharan Africa (developing only)?
Provide a short and direct response. -43.99. In the year 2009, what is the difference between the Total Labor Force (in %) of Middle East & North Africa (developing only) and Total Labor Force (in %) of Liberia?
Your answer should be very brief. -38.71. In the year 2009, what is the difference between the Total Labor Force (in %) of Middle East & North Africa (developing only) and Total Labor Force (in %) of Qatar?
Provide a succinct answer. -30.51. In the year 2009, what is the difference between the Total Labor Force (in %) in Sub-Saharan Africa (developing only) and Total Labor Force (in %) in Liberia?
Offer a very short reply. 5.29. In the year 2009, what is the difference between the Total Labor Force (in %) in Sub-Saharan Africa (developing only) and Total Labor Force (in %) in Qatar?
Your answer should be very brief. 13.49. In the year 2009, what is the difference between the Total Labor Force (in %) in Liberia and Total Labor Force (in %) in Qatar?
Keep it short and to the point. 8.2. In the year 2010, what is the difference between the Total Labor Force (in %) in Middle East & North Africa (developing only) and Total Labor Force (in %) in Sub-Saharan Africa (developing only)?
Offer a very short reply. -43.91. In the year 2010, what is the difference between the Total Labor Force (in %) of Middle East & North Africa (developing only) and Total Labor Force (in %) of Liberia?
Give a very brief answer. -38.56. In the year 2010, what is the difference between the Total Labor Force (in %) of Middle East & North Africa (developing only) and Total Labor Force (in %) of Qatar?
Provide a succinct answer. -30.76. In the year 2010, what is the difference between the Total Labor Force (in %) of Sub-Saharan Africa (developing only) and Total Labor Force (in %) of Liberia?
Your answer should be very brief. 5.35. In the year 2010, what is the difference between the Total Labor Force (in %) in Sub-Saharan Africa (developing only) and Total Labor Force (in %) in Qatar?
Your response must be concise. 13.15. In the year 2011, what is the difference between the Total Labor Force (in %) in Middle East & North Africa (developing only) and Total Labor Force (in %) in Sub-Saharan Africa (developing only)?
Provide a succinct answer. -43.87. In the year 2011, what is the difference between the Total Labor Force (in %) of Middle East & North Africa (developing only) and Total Labor Force (in %) of Liberia?
Ensure brevity in your answer.  -38.47. In the year 2011, what is the difference between the Total Labor Force (in %) in Middle East & North Africa (developing only) and Total Labor Force (in %) in Qatar?
Offer a terse response. -30.77. In the year 2011, what is the difference between the Total Labor Force (in %) in Sub-Saharan Africa (developing only) and Total Labor Force (in %) in Liberia?
Your answer should be very brief. 5.4. In the year 2011, what is the difference between the Total Labor Force (in %) of Sub-Saharan Africa (developing only) and Total Labor Force (in %) of Qatar?
Provide a succinct answer. 13.1. In the year 2011, what is the difference between the Total Labor Force (in %) in Liberia and Total Labor Force (in %) in Qatar?
Offer a terse response. 7.7. In the year 2012, what is the difference between the Total Labor Force (in %) of Middle East & North Africa (developing only) and Total Labor Force (in %) of Sub-Saharan Africa (developing only)?
Your answer should be very brief. -43.83. In the year 2012, what is the difference between the Total Labor Force (in %) in Middle East & North Africa (developing only) and Total Labor Force (in %) in Liberia?
Provide a short and direct response. -38.28. In the year 2012, what is the difference between the Total Labor Force (in %) in Middle East & North Africa (developing only) and Total Labor Force (in %) in Qatar?
Ensure brevity in your answer.  -30.68. In the year 2012, what is the difference between the Total Labor Force (in %) in Sub-Saharan Africa (developing only) and Total Labor Force (in %) in Liberia?
Your answer should be very brief. 5.55. In the year 2012, what is the difference between the Total Labor Force (in %) in Sub-Saharan Africa (developing only) and Total Labor Force (in %) in Qatar?
Your answer should be compact. 13.15. In the year 2013, what is the difference between the Total Labor Force (in %) in Middle East & North Africa (developing only) and Total Labor Force (in %) in Sub-Saharan Africa (developing only)?
Provide a succinct answer. -43.77. In the year 2013, what is the difference between the Total Labor Force (in %) in Middle East & North Africa (developing only) and Total Labor Force (in %) in Liberia?
Provide a short and direct response. -38.2. In the year 2013, what is the difference between the Total Labor Force (in %) in Middle East & North Africa (developing only) and Total Labor Force (in %) in Qatar?
Make the answer very short. -30.5. In the year 2013, what is the difference between the Total Labor Force (in %) of Sub-Saharan Africa (developing only) and Total Labor Force (in %) of Liberia?
Ensure brevity in your answer.  5.57. In the year 2013, what is the difference between the Total Labor Force (in %) in Sub-Saharan Africa (developing only) and Total Labor Force (in %) in Qatar?
Give a very brief answer. 13.27. In the year 2014, what is the difference between the Total Labor Force (in %) in Middle East & North Africa (developing only) and Total Labor Force (in %) in Sub-Saharan Africa (developing only)?
Make the answer very short. -43.69. In the year 2014, what is the difference between the Total Labor Force (in %) of Middle East & North Africa (developing only) and Total Labor Force (in %) of Liberia?
Your response must be concise. -38. In the year 2014, what is the difference between the Total Labor Force (in %) of Middle East & North Africa (developing only) and Total Labor Force (in %) of Qatar?
Offer a terse response. -30.2. In the year 2014, what is the difference between the Total Labor Force (in %) of Sub-Saharan Africa (developing only) and Total Labor Force (in %) of Liberia?
Ensure brevity in your answer.  5.69. In the year 2014, what is the difference between the Total Labor Force (in %) of Sub-Saharan Africa (developing only) and Total Labor Force (in %) of Qatar?
Your response must be concise. 13.49. In the year 2014, what is the difference between the Total Labor Force (in %) of Liberia and Total Labor Force (in %) of Qatar?
Keep it short and to the point. 7.8. What is the ratio of the Total Labor Force (in %) of Middle East & North Africa (developing only) in 2008 to that in 2009?
Give a very brief answer. 1. What is the ratio of the Total Labor Force (in %) of Sub-Saharan Africa (developing only) in 2008 to that in 2009?
Offer a terse response. 1. What is the ratio of the Total Labor Force (in %) of Liberia in 2008 to that in 2009?
Your response must be concise. 1. What is the ratio of the Total Labor Force (in %) of Middle East & North Africa (developing only) in 2008 to that in 2010?
Your answer should be very brief. 0.99. What is the ratio of the Total Labor Force (in %) in Sub-Saharan Africa (developing only) in 2008 to that in 2010?
Offer a terse response. 1. What is the ratio of the Total Labor Force (in %) of Middle East & North Africa (developing only) in 2008 to that in 2011?
Provide a short and direct response. 0.98. What is the ratio of the Total Labor Force (in %) in Liberia in 2008 to that in 2011?
Give a very brief answer. 1. What is the ratio of the Total Labor Force (in %) in Qatar in 2008 to that in 2011?
Provide a short and direct response. 0.99. What is the ratio of the Total Labor Force (in %) of Sub-Saharan Africa (developing only) in 2008 to that in 2012?
Your answer should be compact. 0.99. What is the ratio of the Total Labor Force (in %) of Qatar in 2008 to that in 2012?
Your answer should be very brief. 0.99. What is the ratio of the Total Labor Force (in %) in Middle East & North Africa (developing only) in 2008 to that in 2013?
Keep it short and to the point. 0.96. What is the ratio of the Total Labor Force (in %) of Liberia in 2008 to that in 2013?
Your answer should be very brief. 0.99. What is the ratio of the Total Labor Force (in %) of Qatar in 2008 to that in 2013?
Ensure brevity in your answer.  0.99. What is the ratio of the Total Labor Force (in %) in Middle East & North Africa (developing only) in 2008 to that in 2014?
Offer a very short reply. 0.95. What is the ratio of the Total Labor Force (in %) in Sub-Saharan Africa (developing only) in 2008 to that in 2014?
Make the answer very short. 0.99. What is the ratio of the Total Labor Force (in %) of Liberia in 2008 to that in 2014?
Provide a short and direct response. 0.99. What is the ratio of the Total Labor Force (in %) of Qatar in 2008 to that in 2014?
Your answer should be very brief. 0.99. What is the ratio of the Total Labor Force (in %) in Middle East & North Africa (developing only) in 2009 to that in 2010?
Your answer should be very brief. 0.99. What is the ratio of the Total Labor Force (in %) of Qatar in 2009 to that in 2011?
Your answer should be very brief. 0.99. What is the ratio of the Total Labor Force (in %) in Middle East & North Africa (developing only) in 2009 to that in 2012?
Ensure brevity in your answer.  0.98. What is the ratio of the Total Labor Force (in %) in Sub-Saharan Africa (developing only) in 2009 to that in 2012?
Offer a terse response. 0.99. What is the ratio of the Total Labor Force (in %) of Qatar in 2009 to that in 2012?
Give a very brief answer. 0.99. What is the ratio of the Total Labor Force (in %) of Middle East & North Africa (developing only) in 2009 to that in 2013?
Keep it short and to the point. 0.97. What is the ratio of the Total Labor Force (in %) in Qatar in 2009 to that in 2013?
Provide a short and direct response. 0.99. What is the ratio of the Total Labor Force (in %) of Middle East & North Africa (developing only) in 2009 to that in 2014?
Your answer should be compact. 0.96. What is the ratio of the Total Labor Force (in %) in Sub-Saharan Africa (developing only) in 2009 to that in 2014?
Your answer should be compact. 0.99. What is the ratio of the Total Labor Force (in %) of Liberia in 2009 to that in 2014?
Offer a very short reply. 1. What is the ratio of the Total Labor Force (in %) of Qatar in 2009 to that in 2014?
Ensure brevity in your answer.  0.99. What is the ratio of the Total Labor Force (in %) in Qatar in 2010 to that in 2011?
Offer a very short reply. 1. What is the ratio of the Total Labor Force (in %) in Middle East & North Africa (developing only) in 2010 to that in 2012?
Your answer should be very brief. 0.98. What is the ratio of the Total Labor Force (in %) of Liberia in 2010 to that in 2012?
Give a very brief answer. 1. What is the ratio of the Total Labor Force (in %) of Middle East & North Africa (developing only) in 2010 to that in 2013?
Provide a succinct answer. 0.97. What is the ratio of the Total Labor Force (in %) in Sub-Saharan Africa (developing only) in 2010 to that in 2013?
Offer a very short reply. 0.99. What is the ratio of the Total Labor Force (in %) of Middle East & North Africa (developing only) in 2010 to that in 2014?
Offer a terse response. 0.96. What is the ratio of the Total Labor Force (in %) in Liberia in 2010 to that in 2014?
Provide a short and direct response. 1. What is the ratio of the Total Labor Force (in %) in Qatar in 2010 to that in 2014?
Keep it short and to the point. 1. What is the ratio of the Total Labor Force (in %) in Middle East & North Africa (developing only) in 2011 to that in 2012?
Provide a short and direct response. 0.99. What is the ratio of the Total Labor Force (in %) in Qatar in 2011 to that in 2012?
Your response must be concise. 1. What is the ratio of the Total Labor Force (in %) of Middle East & North Africa (developing only) in 2011 to that in 2013?
Provide a succinct answer. 0.98. What is the ratio of the Total Labor Force (in %) of Liberia in 2011 to that in 2013?
Offer a very short reply. 1. What is the ratio of the Total Labor Force (in %) in Middle East & North Africa (developing only) in 2011 to that in 2014?
Give a very brief answer. 0.97. What is the ratio of the Total Labor Force (in %) in Sub-Saharan Africa (developing only) in 2011 to that in 2014?
Offer a terse response. 0.99. What is the ratio of the Total Labor Force (in %) in Liberia in 2011 to that in 2014?
Make the answer very short. 1. What is the ratio of the Total Labor Force (in %) in Qatar in 2011 to that in 2014?
Keep it short and to the point. 1. What is the ratio of the Total Labor Force (in %) in Middle East & North Africa (developing only) in 2012 to that in 2013?
Provide a succinct answer. 0.99. What is the ratio of the Total Labor Force (in %) of Sub-Saharan Africa (developing only) in 2012 to that in 2013?
Offer a very short reply. 1. What is the ratio of the Total Labor Force (in %) of Qatar in 2012 to that in 2013?
Provide a short and direct response. 1. What is the ratio of the Total Labor Force (in %) in Middle East & North Africa (developing only) in 2012 to that in 2014?
Ensure brevity in your answer.  0.98. What is the ratio of the Total Labor Force (in %) in Sub-Saharan Africa (developing only) in 2012 to that in 2014?
Your response must be concise. 1. What is the ratio of the Total Labor Force (in %) in Liberia in 2012 to that in 2014?
Keep it short and to the point. 1. What is the ratio of the Total Labor Force (in %) in Qatar in 2012 to that in 2014?
Your response must be concise. 1. What is the ratio of the Total Labor Force (in %) in Sub-Saharan Africa (developing only) in 2013 to that in 2014?
Offer a very short reply. 1. What is the ratio of the Total Labor Force (in %) of Qatar in 2013 to that in 2014?
Offer a terse response. 1. What is the difference between the highest and the second highest Total Labor Force (in %) in Middle East & North Africa (developing only)?
Ensure brevity in your answer.  0.2. What is the difference between the highest and the second highest Total Labor Force (in %) of Sub-Saharan Africa (developing only)?
Make the answer very short. 0.12. What is the difference between the highest and the second highest Total Labor Force (in %) of Liberia?
Your answer should be very brief. 0. What is the difference between the highest and the second highest Total Labor Force (in %) in Qatar?
Offer a very short reply. 0. What is the difference between the highest and the lowest Total Labor Force (in %) of Middle East & North Africa (developing only)?
Keep it short and to the point. 0.97. What is the difference between the highest and the lowest Total Labor Force (in %) in Sub-Saharan Africa (developing only)?
Make the answer very short. 0.62. 